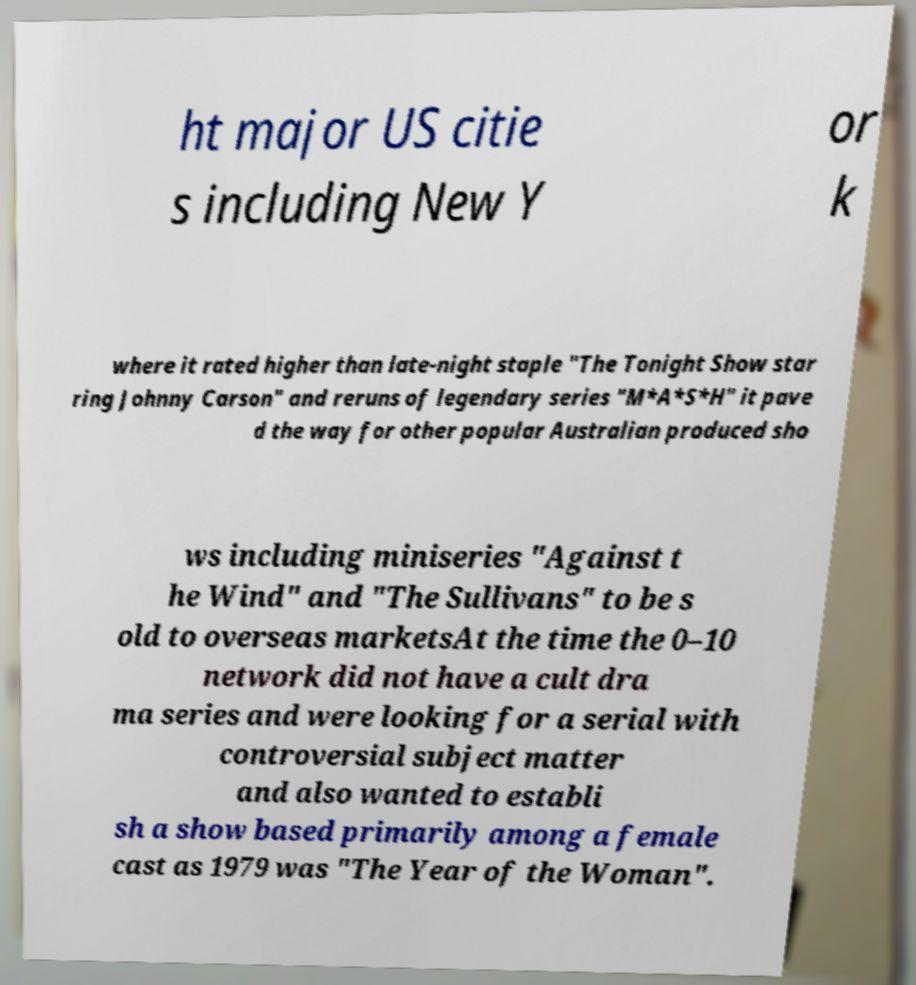Could you extract and type out the text from this image? ht major US citie s including New Y or k where it rated higher than late-night staple "The Tonight Show star ring Johnny Carson" and reruns of legendary series "M*A*S*H" it pave d the way for other popular Australian produced sho ws including miniseries "Against t he Wind" and "The Sullivans" to be s old to overseas marketsAt the time the 0–10 network did not have a cult dra ma series and were looking for a serial with controversial subject matter and also wanted to establi sh a show based primarily among a female cast as 1979 was "The Year of the Woman". 